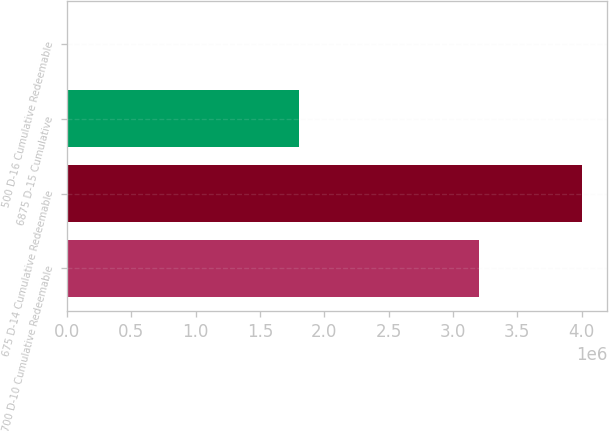<chart> <loc_0><loc_0><loc_500><loc_500><bar_chart><fcel>700 D-10 Cumulative Redeemable<fcel>675 D-14 Cumulative Redeemable<fcel>6875 D-15 Cumulative<fcel>500 D-16 Cumulative Redeemable<nl><fcel>3.2e+06<fcel>4e+06<fcel>1.8e+06<fcel>1<nl></chart> 